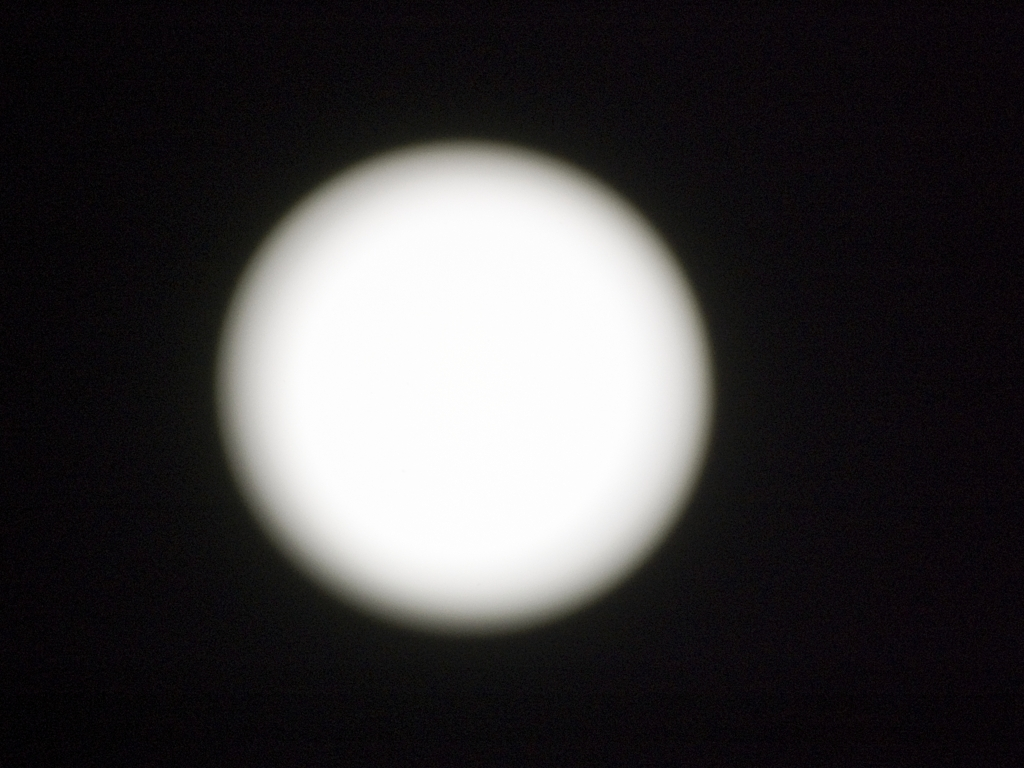How could someone improve the quality of pictures taken of celestial bodies like the one in the image? To improve the quality of such pictures, one would need to use a camera with manual settings to adjust the exposure and focus properly. A tripod could stabilize the shot, and using a longer lens or a telescope with an appropriate camera adapter would allow for closer, more detailed images of celestial bodies. 